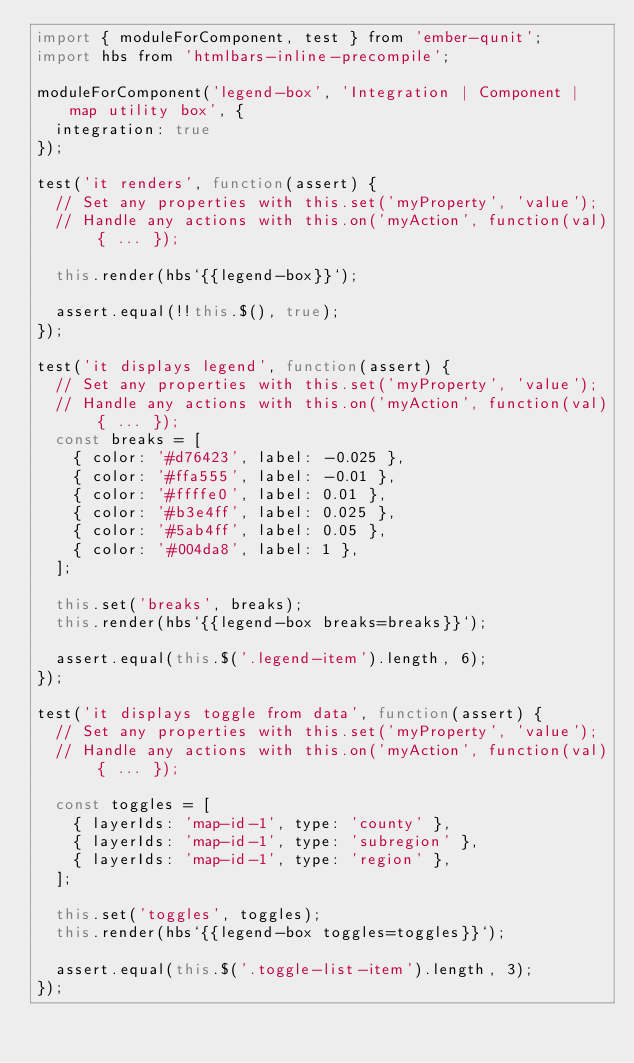Convert code to text. <code><loc_0><loc_0><loc_500><loc_500><_JavaScript_>import { moduleForComponent, test } from 'ember-qunit';
import hbs from 'htmlbars-inline-precompile';

moduleForComponent('legend-box', 'Integration | Component | map utility box', {
  integration: true
});

test('it renders', function(assert) {
  // Set any properties with this.set('myProperty', 'value');
  // Handle any actions with this.on('myAction', function(val) { ... });

  this.render(hbs`{{legend-box}}`);

  assert.equal(!!this.$(), true);
});

test('it displays legend', function(assert) {
  // Set any properties with this.set('myProperty', 'value');
  // Handle any actions with this.on('myAction', function(val) { ... });
  const breaks = [
    { color: '#d76423', label: -0.025 },
    { color: '#ffa555', label: -0.01 },
    { color: '#ffffe0', label: 0.01 },
    { color: '#b3e4ff', label: 0.025 },
    { color: '#5ab4ff', label: 0.05 },
    { color: '#004da8', label: 1 },
  ];

  this.set('breaks', breaks);
  this.render(hbs`{{legend-box breaks=breaks}}`);

  assert.equal(this.$('.legend-item').length, 6);
});

test('it displays toggle from data', function(assert) {
  // Set any properties with this.set('myProperty', 'value');
  // Handle any actions with this.on('myAction', function(val) { ... });

  const toggles = [
    { layerIds: 'map-id-1', type: 'county' },
    { layerIds: 'map-id-1', type: 'subregion' },
    { layerIds: 'map-id-1', type: 'region' },
  ];

  this.set('toggles', toggles);
  this.render(hbs`{{legend-box toggles=toggles}}`);

  assert.equal(this.$('.toggle-list-item').length, 3);
});
</code> 